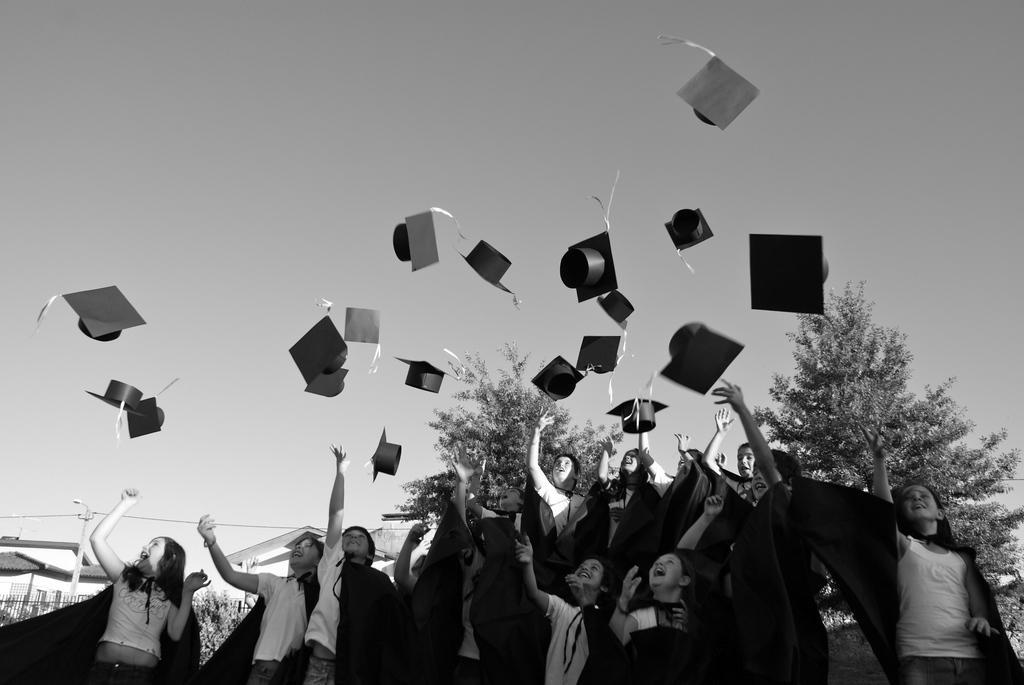Please provide a concise description of this image. In this image I can see the black and white picture in which I can see number of persons are standing and I can see few hats in the air. In the background I can see few trees, few buildings and the sky. 